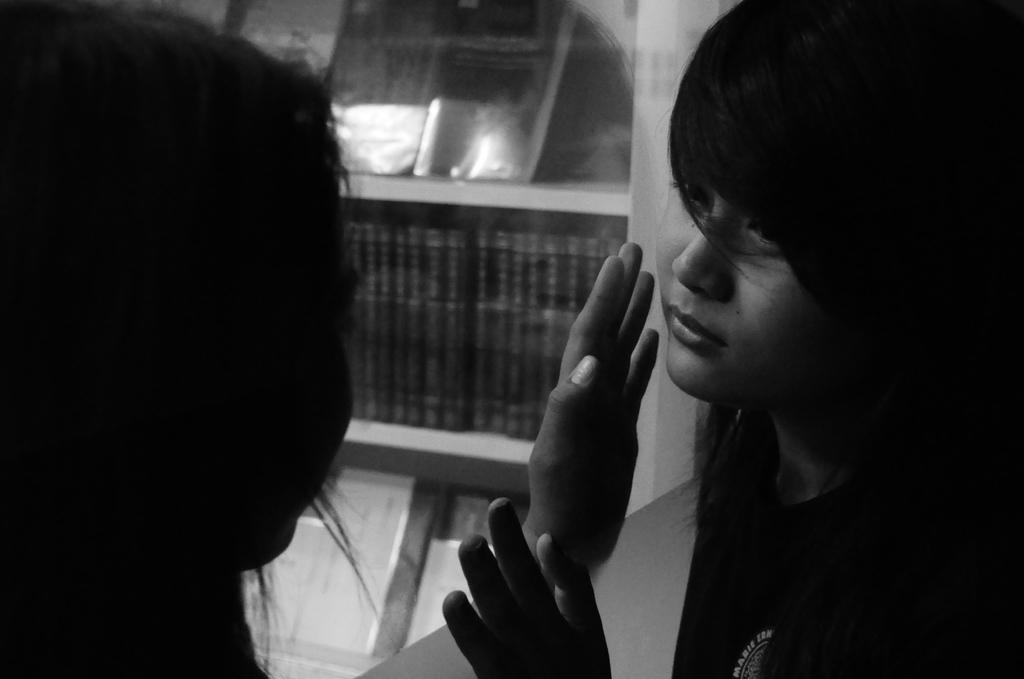What is the color scheme of the image? The image is black and white. How many people are in the image? There are two persons standing in the image. What are the positions of the persons in the image? The persons are standing in opposite directions. What can be seen in the background of the image? There are books visible on shelves in the background of the image. What type of ship can be seen sailing in the background of the image? There is no ship present in the image; it is a black and white image with two persons standing in opposite directions and books visible on shelves in the background. 